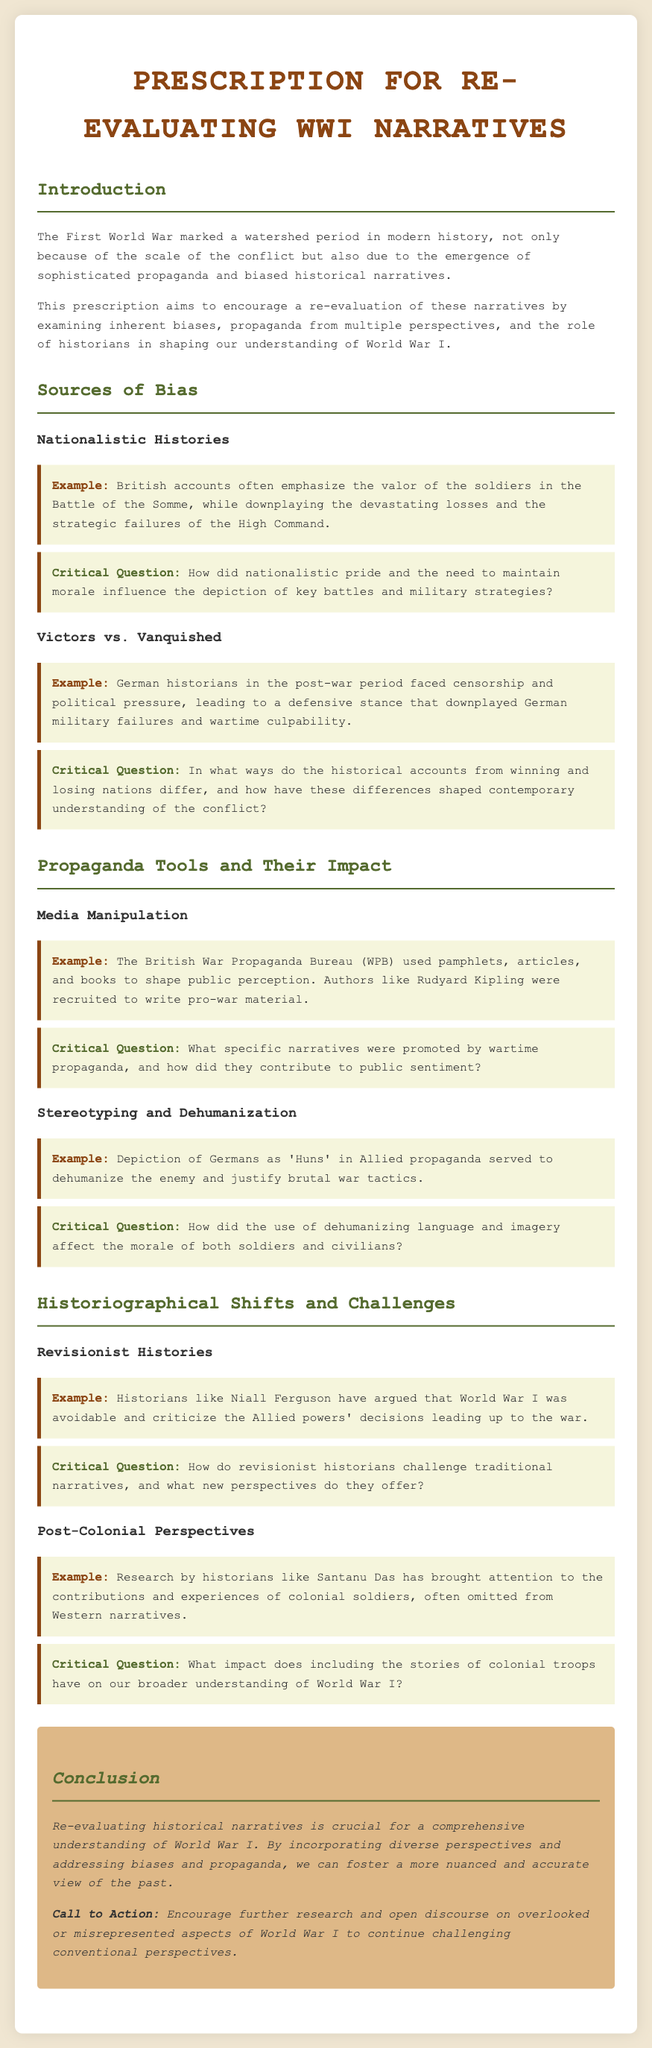What is the title of the document? The title can be found in the header section of the document.
Answer: Prescription for Re-Evaluating WWI Narratives Who is mentioned as a historian that argues World War I was avoidable? This information is provided under the section about revisionist histories.
Answer: Niall Ferguson What term was used in Allied propaganda to refer to Germans? This term is specifically noted under the discussion of stereotyping and dehumanization.
Answer: Huns What does the section on post-colonial perspectives highlight? This section covers the contributions and experiences of a specific group often omitted from narratives.
Answer: Colonial soldiers What was the role of the British War Propaganda Bureau? This information can be found under the section discussing media manipulation.
Answer: Shape public perception How does the conclusion suggest we can foster a more accurate view of the past? The conclusion offers a call to action that relates to research and discourse.
Answer: Incorporating diverse perspectives 